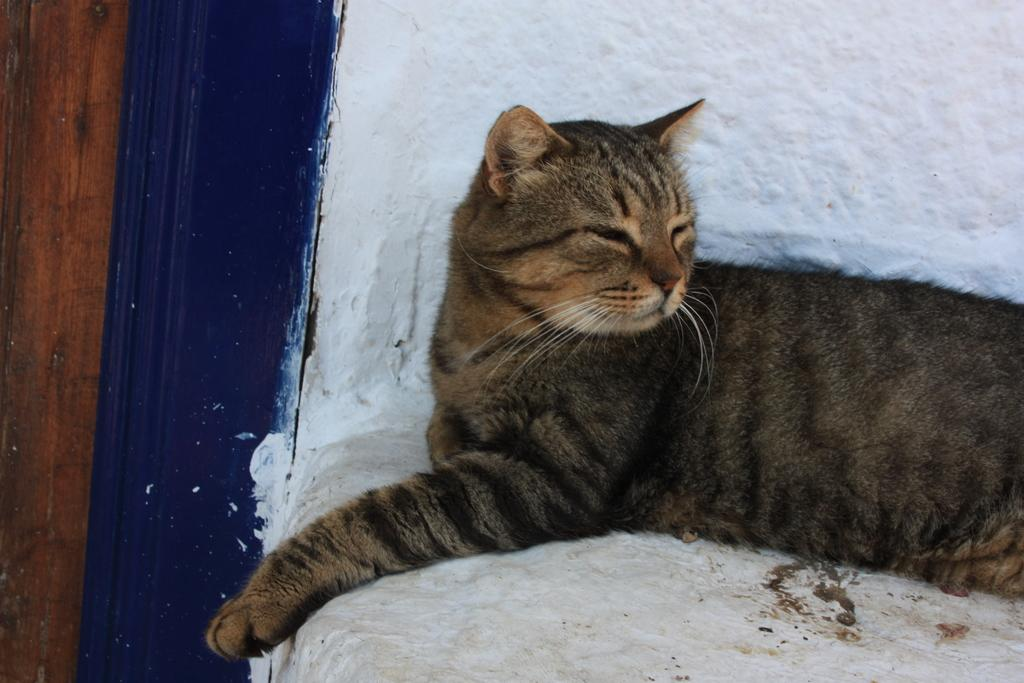What type of animal is in the image? There is a cat in the image. Where is the cat located? The cat is on a wall. What else can be seen in the image besides the cat? There is a door visible in the image. What type of leather material is covering the car in the image? There is no car present in the image, so there is no leather material to be observed. 